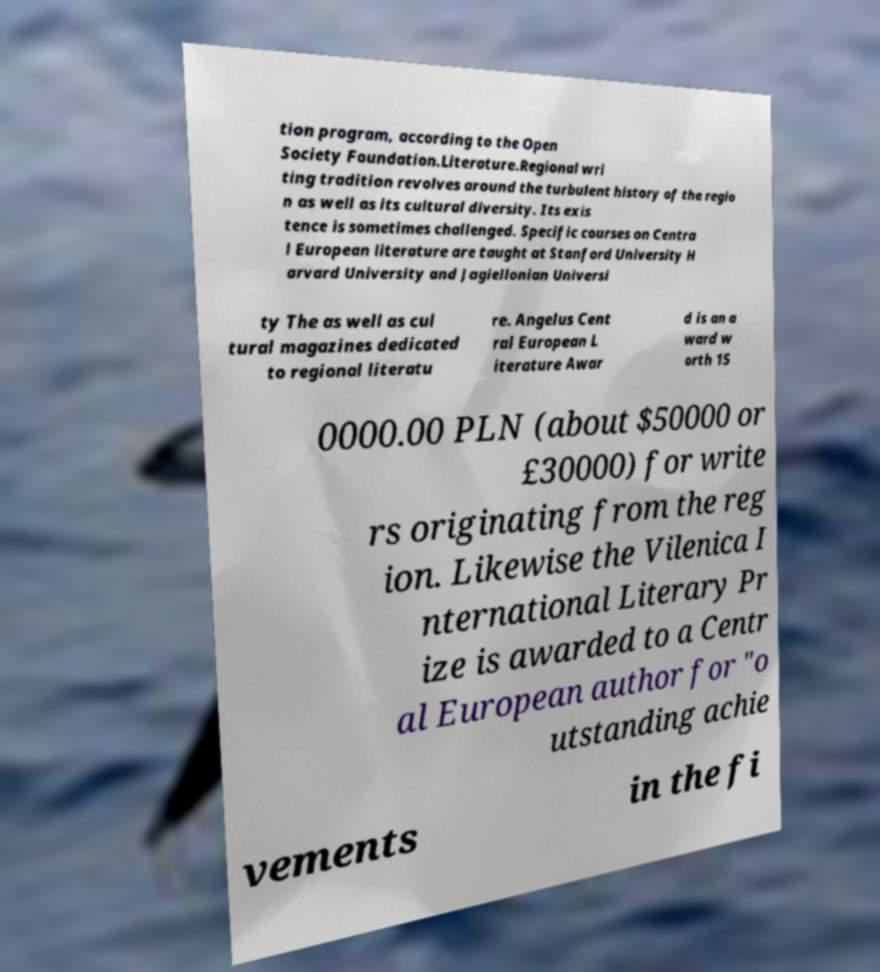Please identify and transcribe the text found in this image. tion program, according to the Open Society Foundation.Literature.Regional wri ting tradition revolves around the turbulent history of the regio n as well as its cultural diversity. Its exis tence is sometimes challenged. Specific courses on Centra l European literature are taught at Stanford University H arvard University and Jagiellonian Universi ty The as well as cul tural magazines dedicated to regional literatu re. Angelus Cent ral European L iterature Awar d is an a ward w orth 15 0000.00 PLN (about $50000 or £30000) for write rs originating from the reg ion. Likewise the Vilenica I nternational Literary Pr ize is awarded to a Centr al European author for "o utstanding achie vements in the fi 